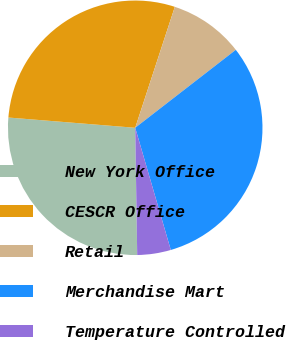Convert chart to OTSL. <chart><loc_0><loc_0><loc_500><loc_500><pie_chart><fcel>New York Office<fcel>CESCR Office<fcel>Retail<fcel>Merchandise Mart<fcel>Temperature Controlled<nl><fcel>26.53%<fcel>28.75%<fcel>9.47%<fcel>30.98%<fcel>4.26%<nl></chart> 